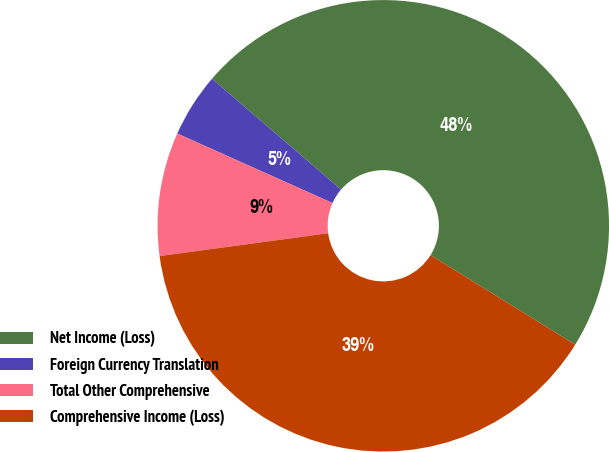Convert chart to OTSL. <chart><loc_0><loc_0><loc_500><loc_500><pie_chart><fcel>Net Income (Loss)<fcel>Foreign Currency Translation<fcel>Total Other Comprehensive<fcel>Comprehensive Income (Loss)<nl><fcel>47.54%<fcel>4.59%<fcel>8.84%<fcel>39.03%<nl></chart> 